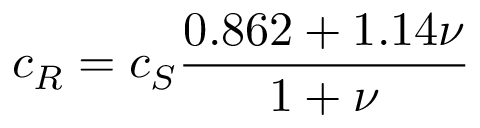<formula> <loc_0><loc_0><loc_500><loc_500>c _ { R } = c _ { S } { \frac { 0 . 8 6 2 + 1 . 1 4 \nu } { 1 + \nu } }</formula> 